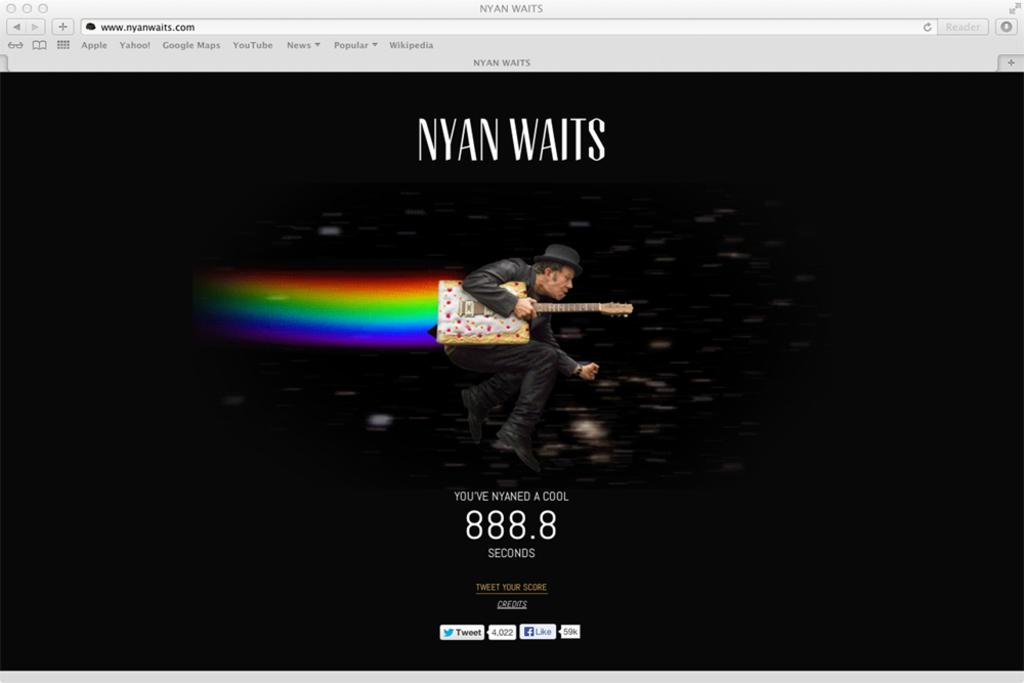What is the main object visible on the computer screen in the image? The provided facts do not mention any specific content on the computer screen. What is the man holding in the image? The man is holding a guitar in the image. How would you describe the lighting in the image? The background of the image is dark. How much does the mask cost in the image? There is no mask present in the image, so it is not possible to determine its price. What type of quarter is visible on the computer screen? There is no mention of a quarter or any specific content on the computer screen in the provided facts. 